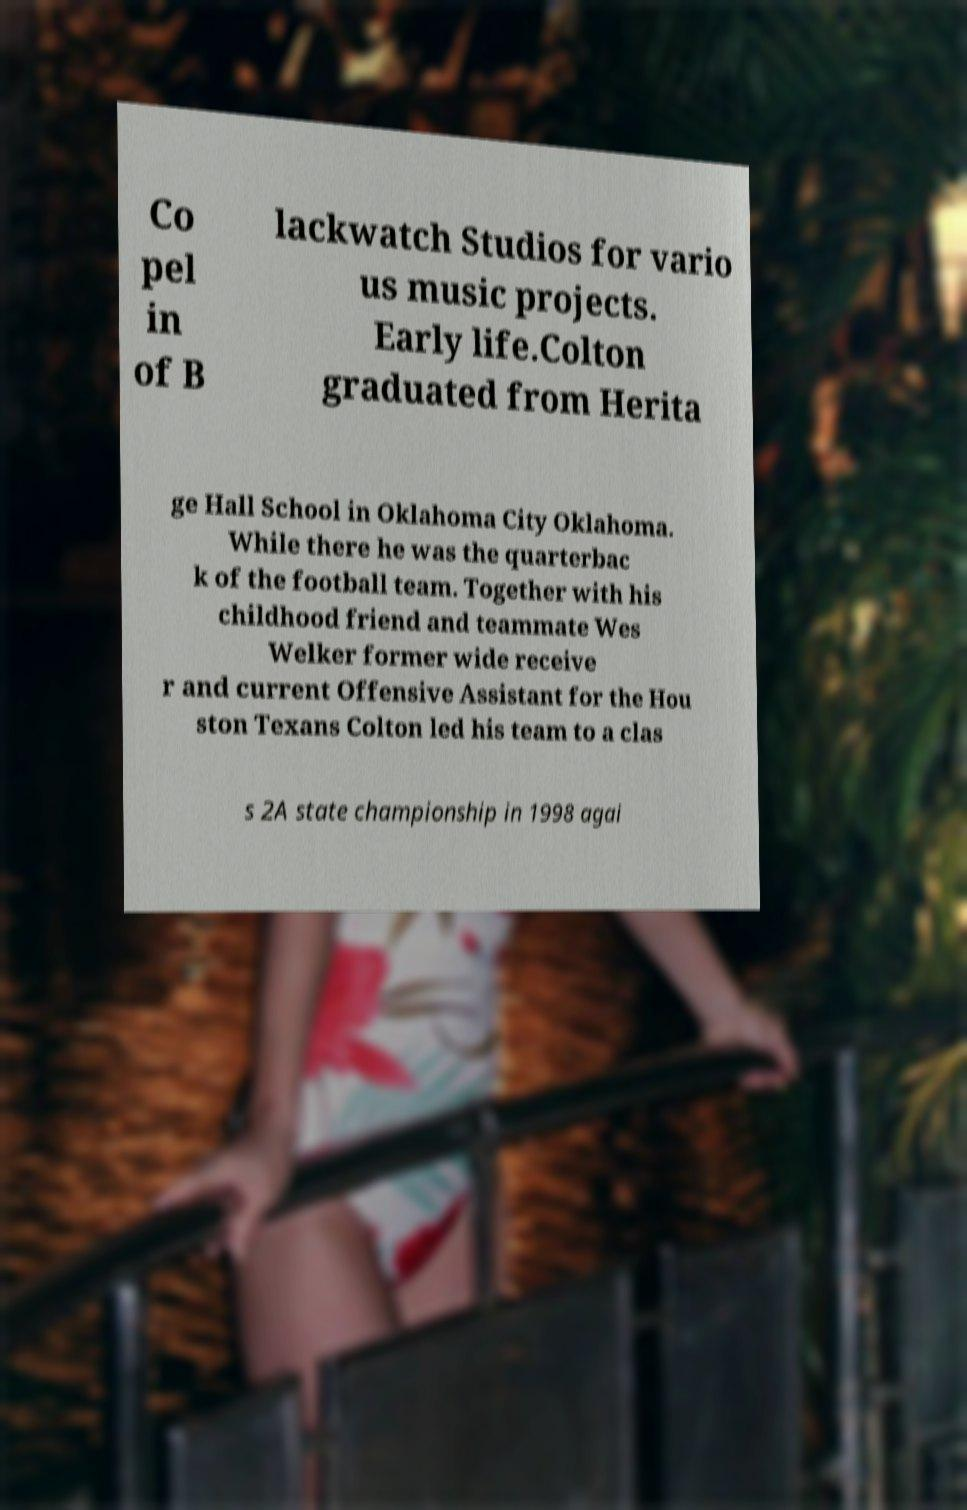Could you extract and type out the text from this image? Co pel in of B lackwatch Studios for vario us music projects. Early life.Colton graduated from Herita ge Hall School in Oklahoma City Oklahoma. While there he was the quarterbac k of the football team. Together with his childhood friend and teammate Wes Welker former wide receive r and current Offensive Assistant for the Hou ston Texans Colton led his team to a clas s 2A state championship in 1998 agai 